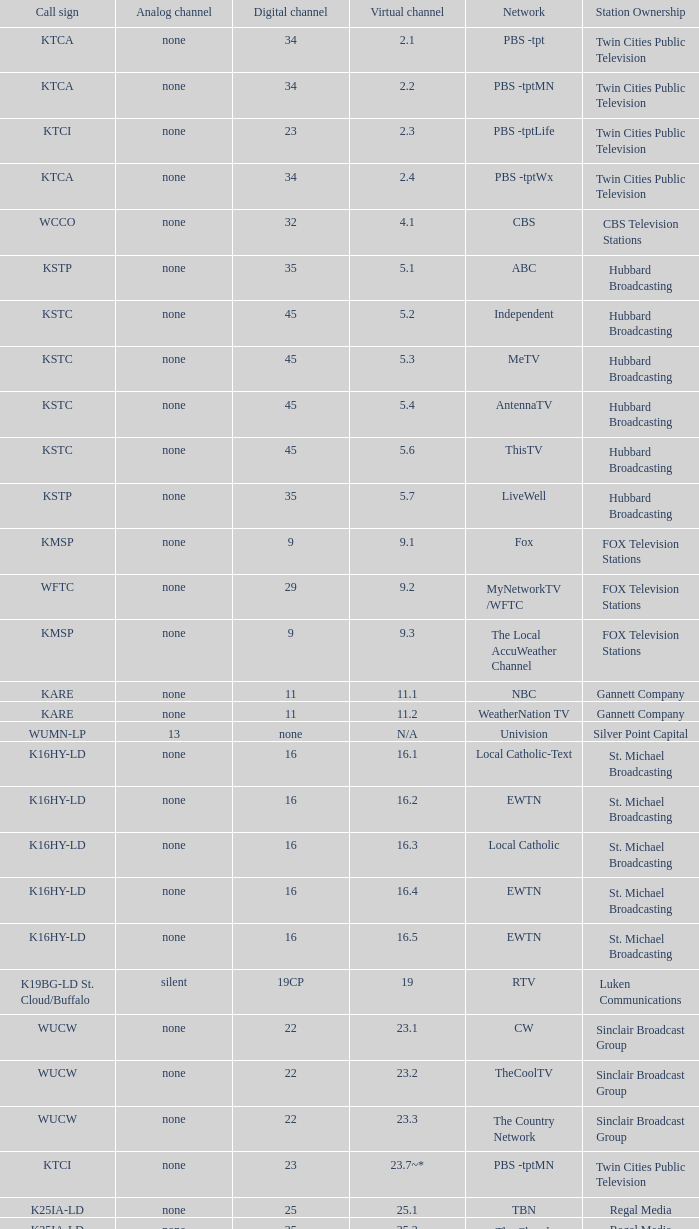Call sign of k43hb-ld is what virtual channel? 43.1. 